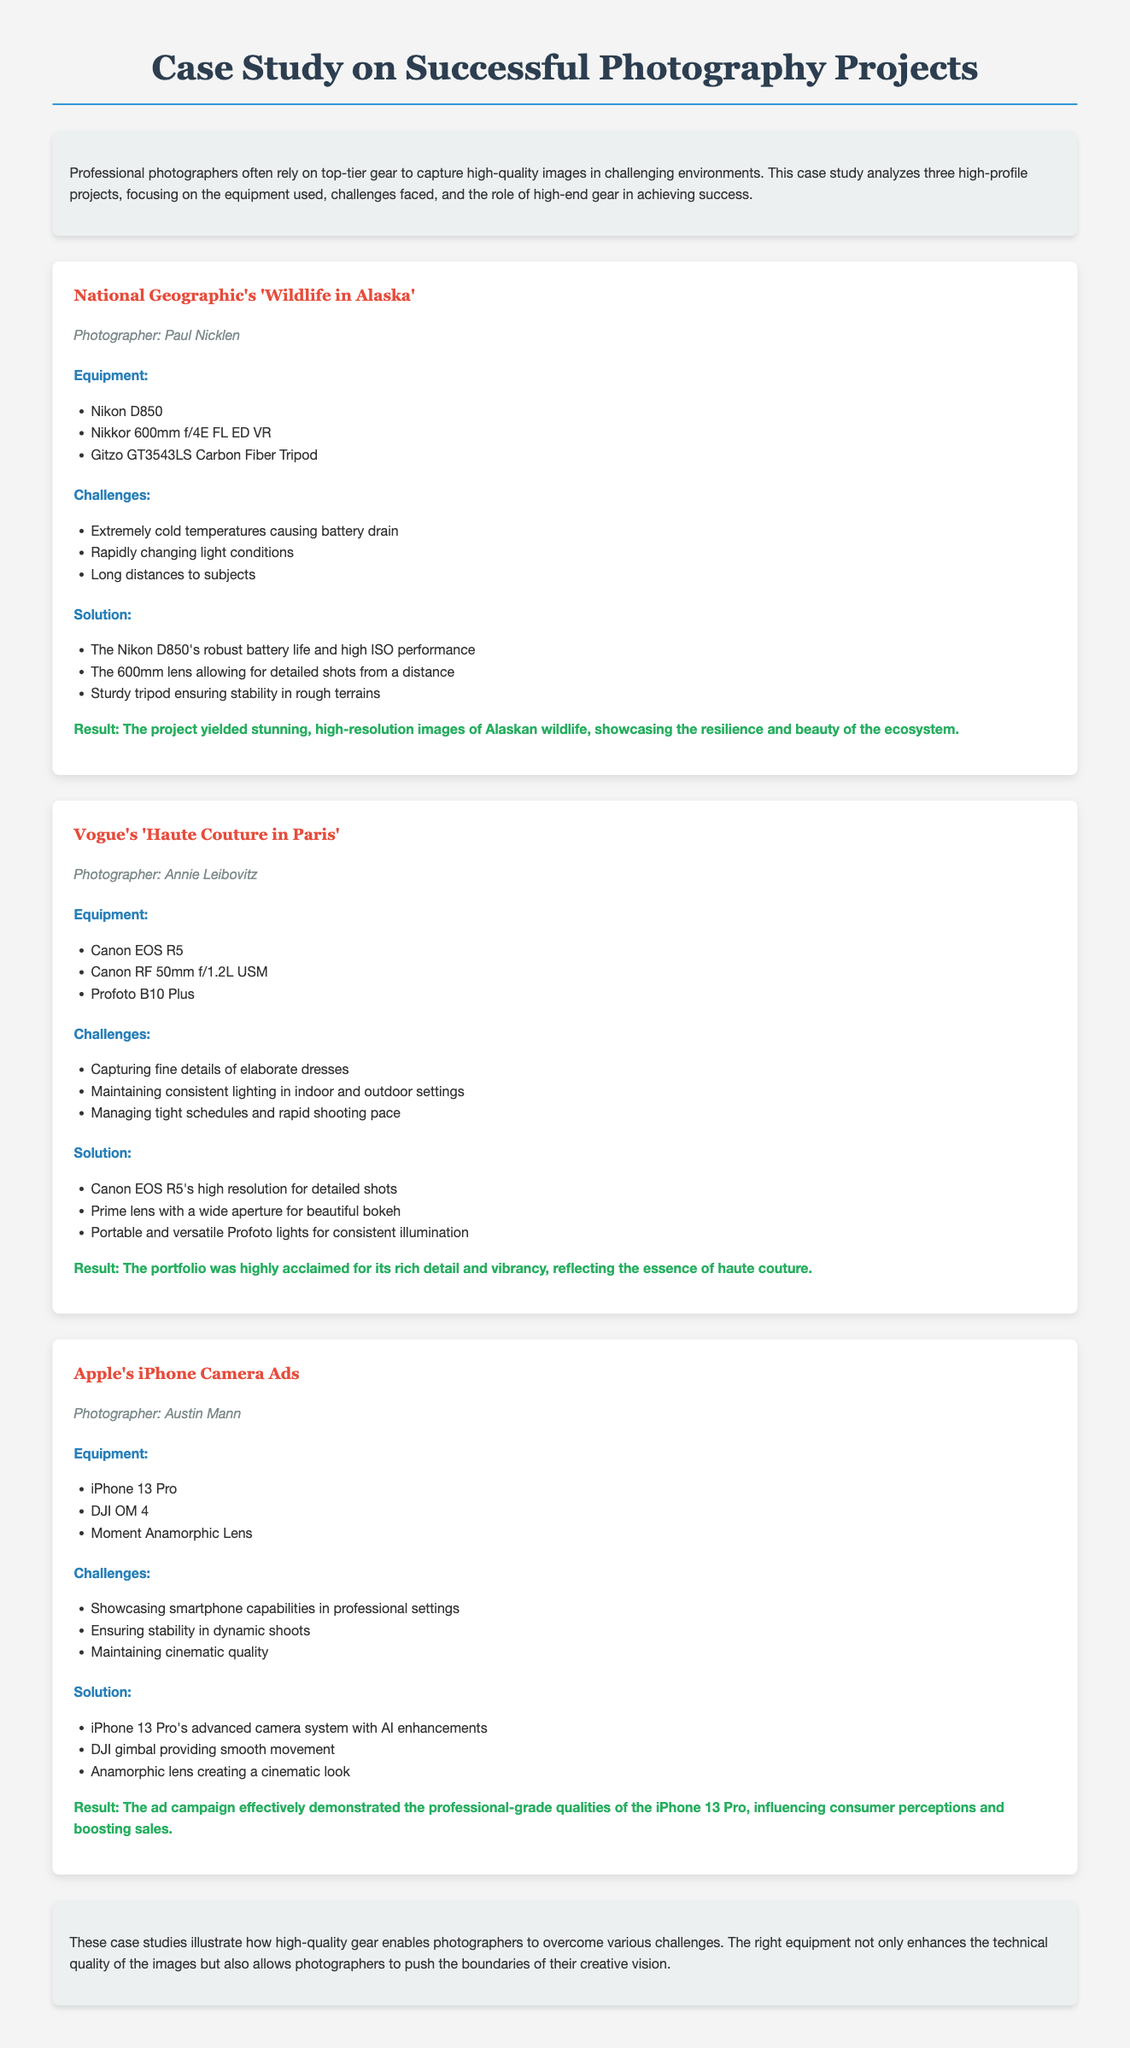What is the title of the first project? The title of the first project is presented at the beginning of the respective section in the document.
Answer: Wildlife in Alaska Who is the photographer for Vogue's project? The photographer's name for the Vogue project is listed below the project title.
Answer: Annie Leibovitz What equipment was used in Apple's iPhone Camera Ads? The equipment used is mentioned in a bulleted list under the project description.
Answer: iPhone 13 Pro What challenge did Paul Nicklen face during his project? Challenges faced by each photographer are detailed in the document and relate to specific project conditions.
Answer: Extremely cold temperatures causing battery drain What solution was used to ensure stability in the dynamic shoots of the iPhone ads? The solutions provided in the document describe how challenges were addressed, specifically for stability.
Answer: DJI gimbal providing smooth movement How many projects are analyzed in the case study? The total number of projects analyzed can be counted from the document structure, each headlined as a separate project.
Answer: Three What is the overall result of the Vogue project? The results for each project are summarized in a concluding sentence, reflecting on the project's success.
Answer: The portfolio was highly acclaimed for its rich detail and vibrancy Which lens was used by Paul Nicklen? The specific equipment used in his project is listed clearly under the equipment section of his project.
Answer: Nikkor 600mm f/4E FL ED VR What color is used for the project titles? The document provides stylistic details such as colors used for headings, which can be identified visually.
Answer: Red 